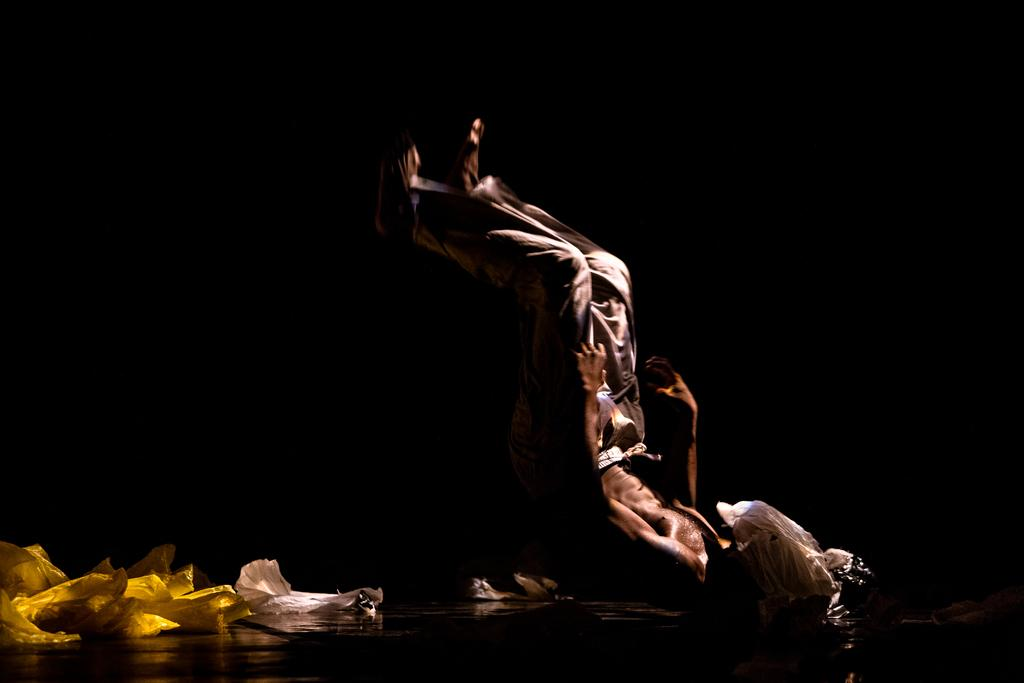Who or what is the main subject in the middle of the image? There is a person in the middle of the image. What can be seen at the left bottom of the image? There are clothes at the left bottom of the image. How would you describe the overall lighting or color of the image? The background of the image is dark. How many icicles are hanging from the person's grip in the image? There are no icicles present in the image, and the person's grip is not visible. 